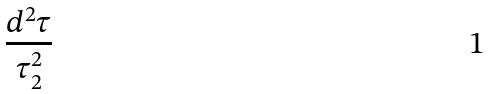<formula> <loc_0><loc_0><loc_500><loc_500>\frac { d ^ { 2 } \tau } { \tau _ { 2 } ^ { 2 } }</formula> 